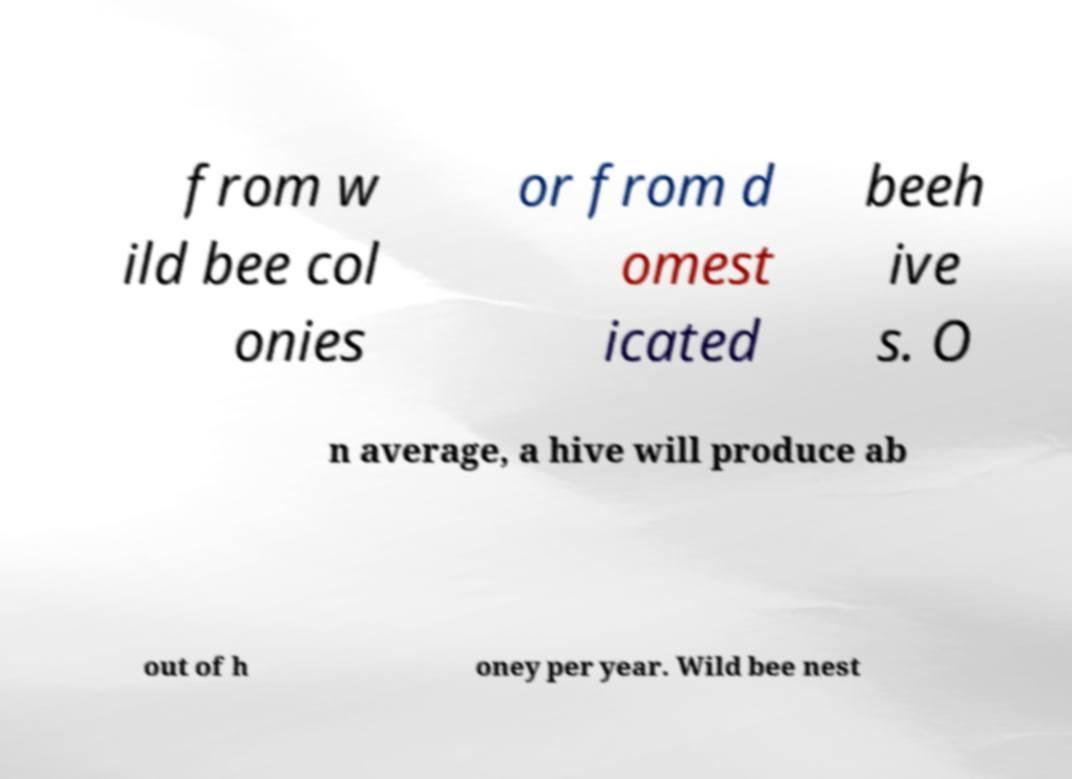Please read and relay the text visible in this image. What does it say? from w ild bee col onies or from d omest icated beeh ive s. O n average, a hive will produce ab out of h oney per year. Wild bee nest 